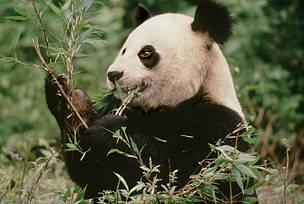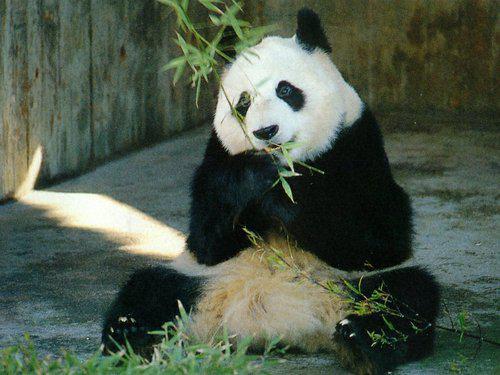The first image is the image on the left, the second image is the image on the right. Assess this claim about the two images: "There are two pandas in the image on the right.". Correct or not? Answer yes or no. No. 